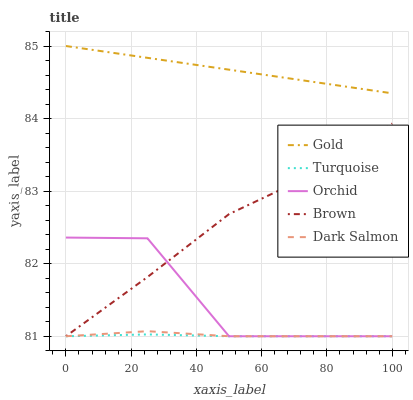Does Turquoise have the minimum area under the curve?
Answer yes or no. Yes. Does Gold have the maximum area under the curve?
Answer yes or no. Yes. Does Dark Salmon have the minimum area under the curve?
Answer yes or no. No. Does Dark Salmon have the maximum area under the curve?
Answer yes or no. No. Is Gold the smoothest?
Answer yes or no. Yes. Is Orchid the roughest?
Answer yes or no. Yes. Is Turquoise the smoothest?
Answer yes or no. No. Is Turquoise the roughest?
Answer yes or no. No. Does Brown have the lowest value?
Answer yes or no. Yes. Does Gold have the lowest value?
Answer yes or no. No. Does Gold have the highest value?
Answer yes or no. Yes. Does Dark Salmon have the highest value?
Answer yes or no. No. Is Brown less than Gold?
Answer yes or no. Yes. Is Gold greater than Turquoise?
Answer yes or no. Yes. Does Orchid intersect Turquoise?
Answer yes or no. Yes. Is Orchid less than Turquoise?
Answer yes or no. No. Is Orchid greater than Turquoise?
Answer yes or no. No. Does Brown intersect Gold?
Answer yes or no. No. 